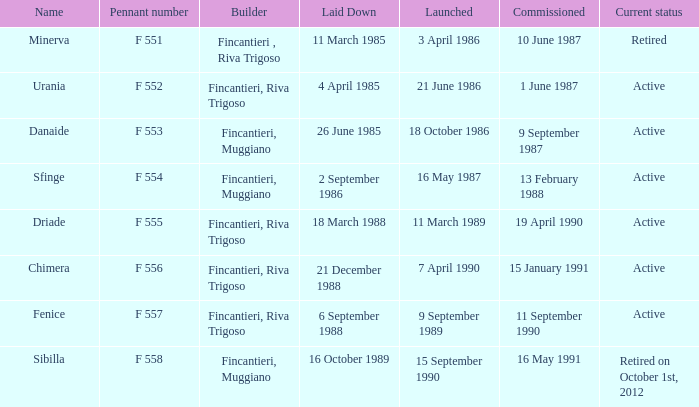Which constructor is currently retired? F 551. Can you give me this table as a dict? {'header': ['Name', 'Pennant number', 'Builder', 'Laid Down', 'Launched', 'Commissioned', 'Current status'], 'rows': [['Minerva', 'F 551', 'Fincantieri , Riva Trigoso', '11 March 1985', '3 April 1986', '10 June 1987', 'Retired'], ['Urania', 'F 552', 'Fincantieri, Riva Trigoso', '4 April 1985', '21 June 1986', '1 June 1987', 'Active'], ['Danaide', 'F 553', 'Fincantieri, Muggiano', '26 June 1985', '18 October 1986', '9 September 1987', 'Active'], ['Sfinge', 'F 554', 'Fincantieri, Muggiano', '2 September 1986', '16 May 1987', '13 February 1988', 'Active'], ['Driade', 'F 555', 'Fincantieri, Riva Trigoso', '18 March 1988', '11 March 1989', '19 April 1990', 'Active'], ['Chimera', 'F 556', 'Fincantieri, Riva Trigoso', '21 December 1988', '7 April 1990', '15 January 1991', 'Active'], ['Fenice', 'F 557', 'Fincantieri, Riva Trigoso', '6 September 1988', '9 September 1989', '11 September 1990', 'Active'], ['Sibilla', 'F 558', 'Fincantieri, Muggiano', '16 October 1989', '15 September 1990', '16 May 1991', 'Retired on October 1st, 2012']]} 